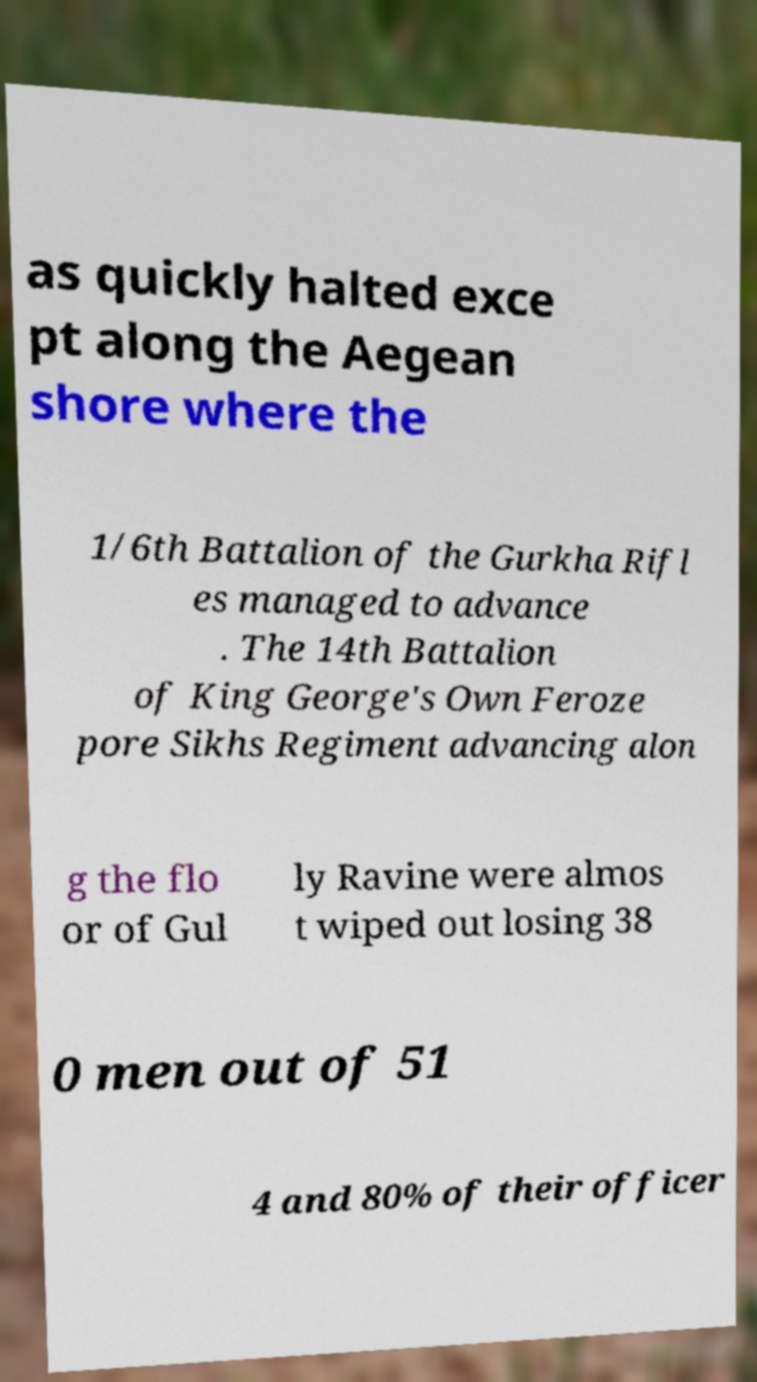Please read and relay the text visible in this image. What does it say? as quickly halted exce pt along the Aegean shore where the 1/6th Battalion of the Gurkha Rifl es managed to advance . The 14th Battalion of King George's Own Feroze pore Sikhs Regiment advancing alon g the flo or of Gul ly Ravine were almos t wiped out losing 38 0 men out of 51 4 and 80% of their officer 